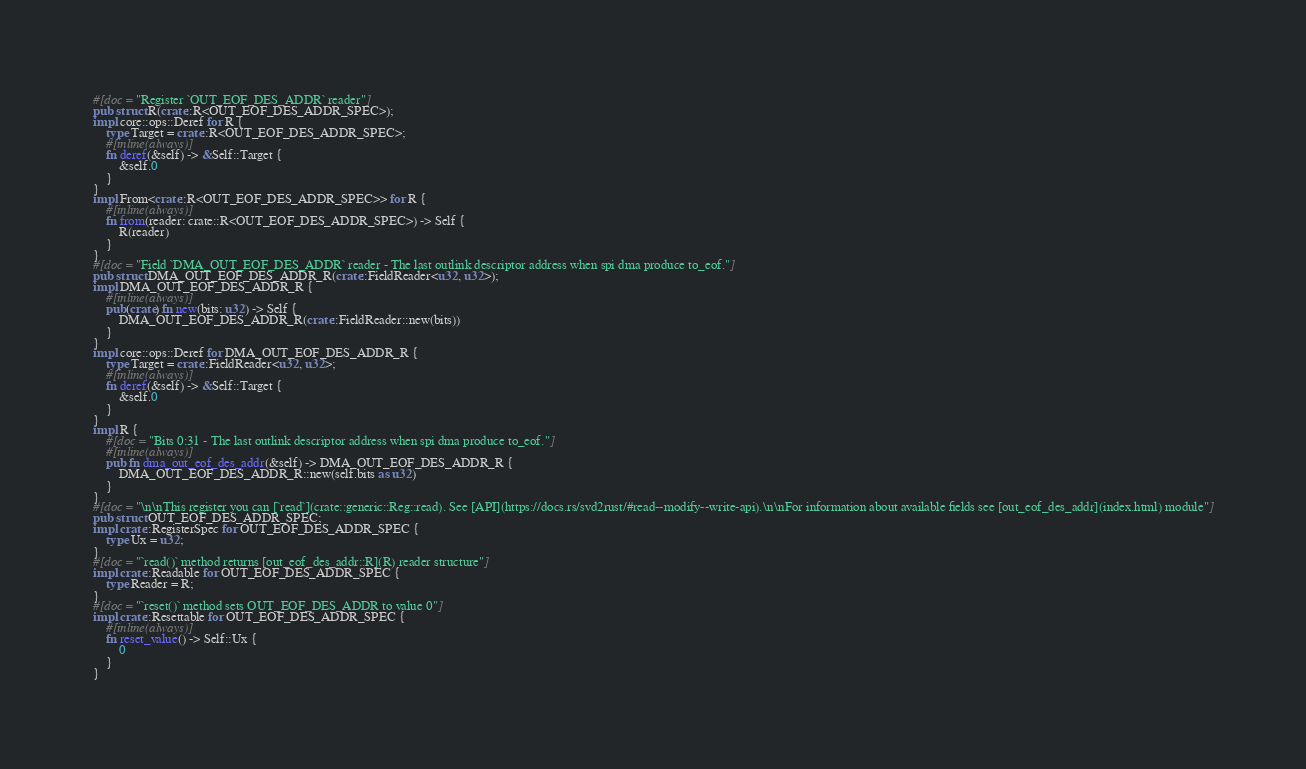Convert code to text. <code><loc_0><loc_0><loc_500><loc_500><_Rust_>#[doc = "Register `OUT_EOF_DES_ADDR` reader"]
pub struct R(crate::R<OUT_EOF_DES_ADDR_SPEC>);
impl core::ops::Deref for R {
    type Target = crate::R<OUT_EOF_DES_ADDR_SPEC>;
    #[inline(always)]
    fn deref(&self) -> &Self::Target {
        &self.0
    }
}
impl From<crate::R<OUT_EOF_DES_ADDR_SPEC>> for R {
    #[inline(always)]
    fn from(reader: crate::R<OUT_EOF_DES_ADDR_SPEC>) -> Self {
        R(reader)
    }
}
#[doc = "Field `DMA_OUT_EOF_DES_ADDR` reader - The last outlink descriptor address when spi dma produce to_eof."]
pub struct DMA_OUT_EOF_DES_ADDR_R(crate::FieldReader<u32, u32>);
impl DMA_OUT_EOF_DES_ADDR_R {
    #[inline(always)]
    pub(crate) fn new(bits: u32) -> Self {
        DMA_OUT_EOF_DES_ADDR_R(crate::FieldReader::new(bits))
    }
}
impl core::ops::Deref for DMA_OUT_EOF_DES_ADDR_R {
    type Target = crate::FieldReader<u32, u32>;
    #[inline(always)]
    fn deref(&self) -> &Self::Target {
        &self.0
    }
}
impl R {
    #[doc = "Bits 0:31 - The last outlink descriptor address when spi dma produce to_eof."]
    #[inline(always)]
    pub fn dma_out_eof_des_addr(&self) -> DMA_OUT_EOF_DES_ADDR_R {
        DMA_OUT_EOF_DES_ADDR_R::new(self.bits as u32)
    }
}
#[doc = "\n\nThis register you can [`read`](crate::generic::Reg::read). See [API](https://docs.rs/svd2rust/#read--modify--write-api).\n\nFor information about available fields see [out_eof_des_addr](index.html) module"]
pub struct OUT_EOF_DES_ADDR_SPEC;
impl crate::RegisterSpec for OUT_EOF_DES_ADDR_SPEC {
    type Ux = u32;
}
#[doc = "`read()` method returns [out_eof_des_addr::R](R) reader structure"]
impl crate::Readable for OUT_EOF_DES_ADDR_SPEC {
    type Reader = R;
}
#[doc = "`reset()` method sets OUT_EOF_DES_ADDR to value 0"]
impl crate::Resettable for OUT_EOF_DES_ADDR_SPEC {
    #[inline(always)]
    fn reset_value() -> Self::Ux {
        0
    }
}
</code> 